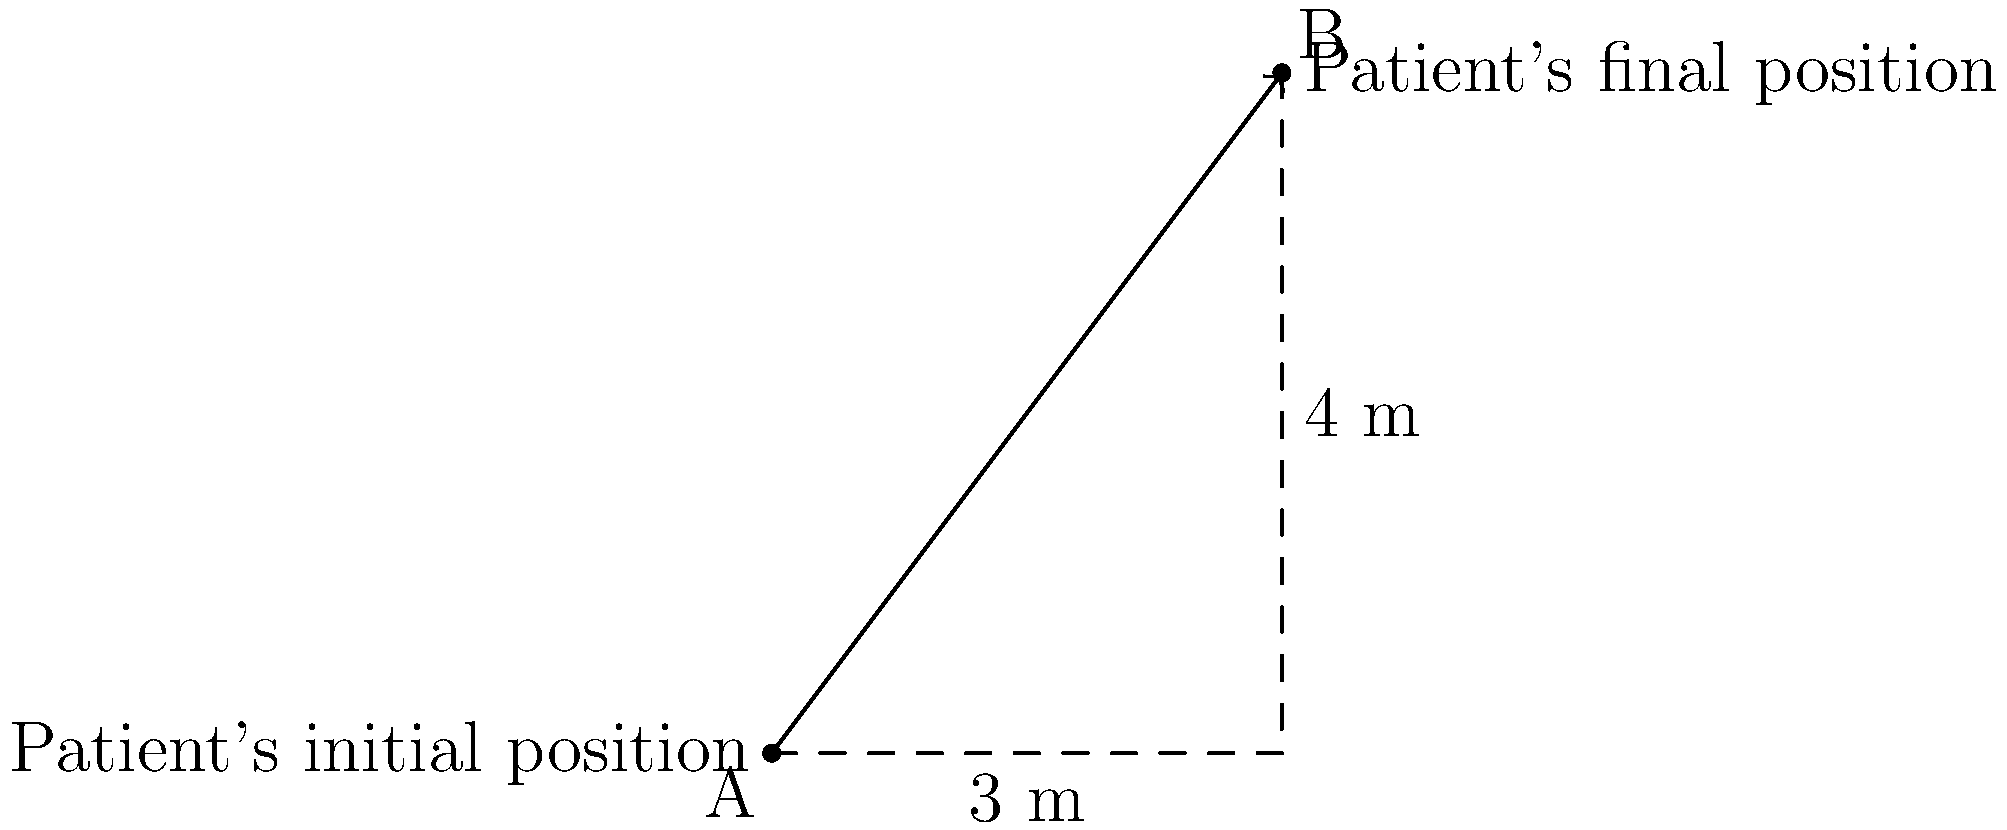In the hospital ward, a patient needs to be moved from bed A to bed B. The movement can be represented by a vector, as shown in the diagram. If the horizontal distance between the beds is 3 meters and the vertical distance is 4 meters, what is the magnitude of the vector representing the patient's movement? To find the magnitude of the vector representing the patient's movement, we can use the Pythagorean theorem. Let's approach this step-by-step:

1) The vector has two components:
   - Horizontal component: 3 meters
   - Vertical component: 4 meters

2) We can think of this as a right-angled triangle, where the vector is the hypotenuse.

3) The Pythagorean theorem states that in a right-angled triangle:
   $a^2 + b^2 = c^2$
   where $c$ is the hypotenuse (our vector magnitude), and $a$ and $b$ are the other two sides.

4) Let's substitute our values:
   $3^2 + 4^2 = c^2$

5) Simplify:
   $9 + 16 = c^2$
   $25 = c^2$

6) To find $c$, we need to take the square root of both sides:
   $\sqrt{25} = c$

7) Simplify:
   $c = 5$

Therefore, the magnitude of the vector representing the patient's movement is 5 meters.
Answer: 5 meters 